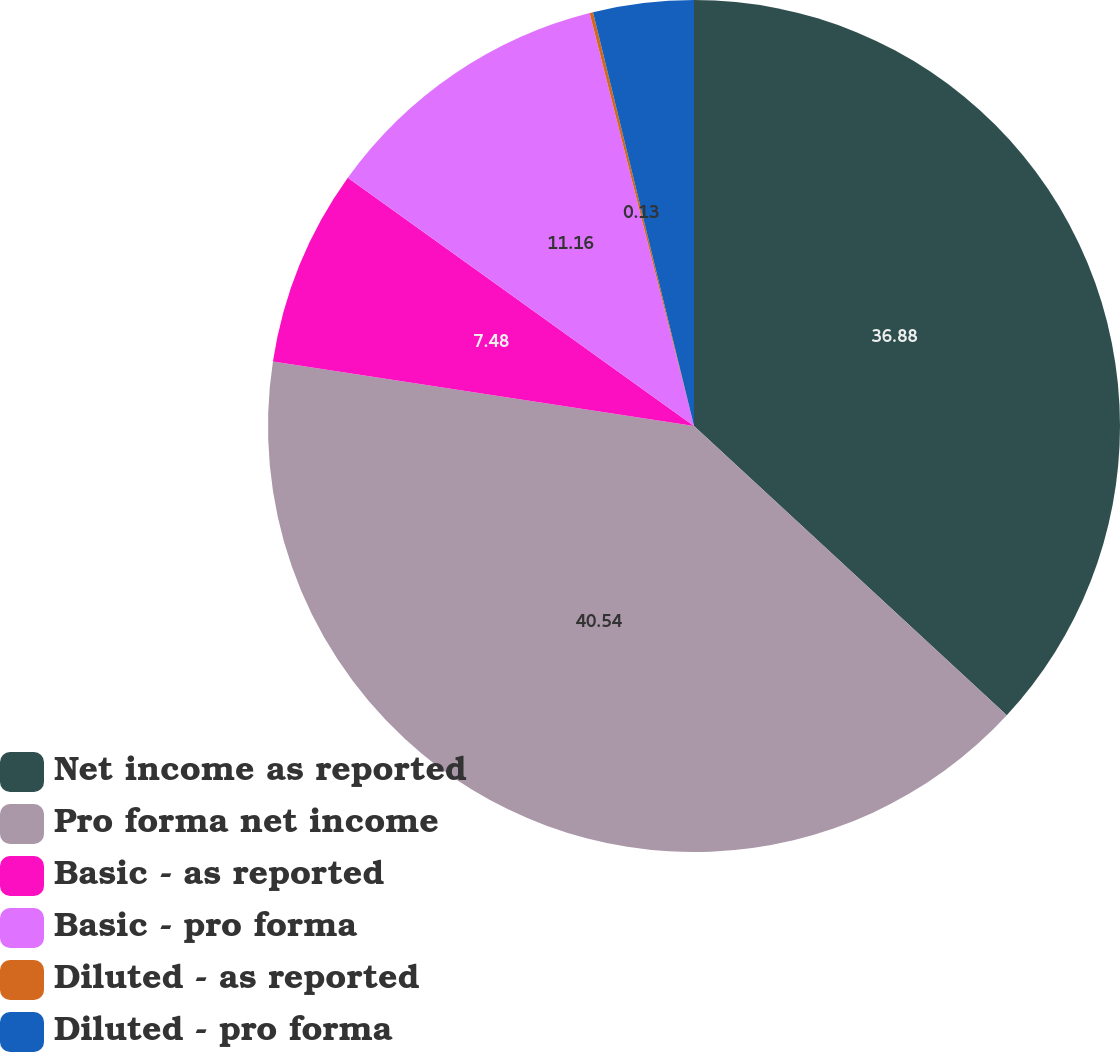Convert chart. <chart><loc_0><loc_0><loc_500><loc_500><pie_chart><fcel>Net income as reported<fcel>Pro forma net income<fcel>Basic - as reported<fcel>Basic - pro forma<fcel>Diluted - as reported<fcel>Diluted - pro forma<nl><fcel>36.88%<fcel>40.55%<fcel>7.48%<fcel>11.16%<fcel>0.13%<fcel>3.81%<nl></chart> 